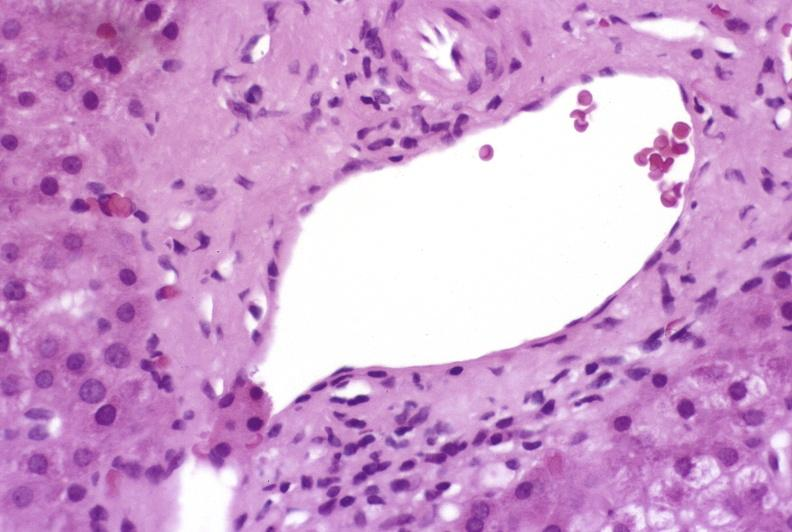s hemorrhage associated with placental abruption present?
Answer the question using a single word or phrase. No 